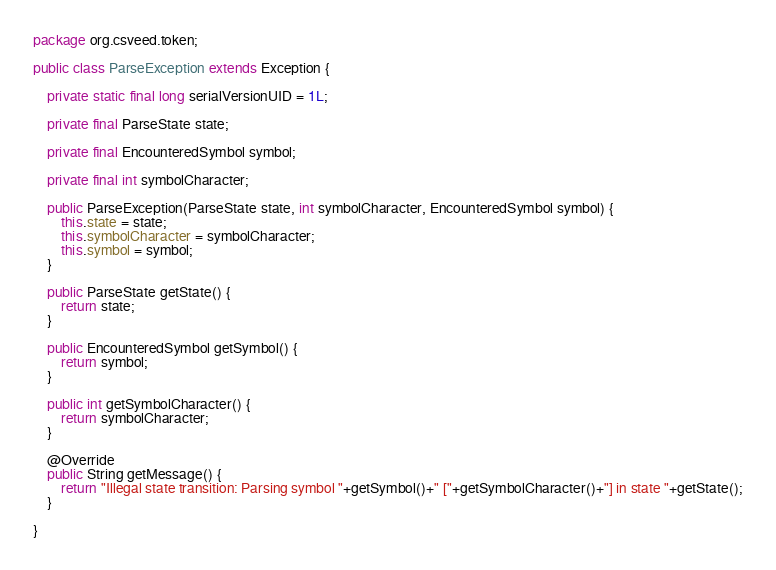<code> <loc_0><loc_0><loc_500><loc_500><_Java_>package org.csveed.token;

public class ParseException extends Exception {

    private static final long serialVersionUID = 1L;

    private final ParseState state;

    private final EncounteredSymbol symbol;

    private final int symbolCharacter;

    public ParseException(ParseState state, int symbolCharacter, EncounteredSymbol symbol) {
        this.state = state;
        this.symbolCharacter = symbolCharacter;
        this.symbol = symbol;
    }

    public ParseState getState() {
        return state;
    }

    public EncounteredSymbol getSymbol() {
        return symbol;
    }

    public int getSymbolCharacter() {
        return symbolCharacter;
    }

    @Override
    public String getMessage() {
        return "Illegal state transition: Parsing symbol "+getSymbol()+" ["+getSymbolCharacter()+"] in state "+getState();
    }

}
</code> 